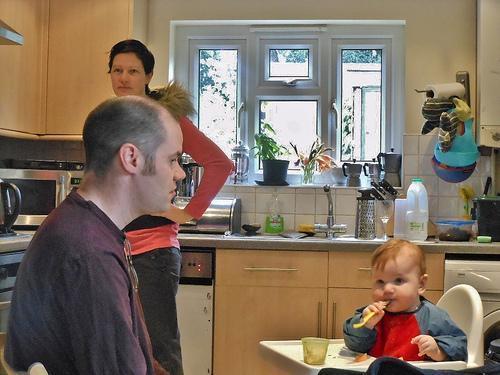How many objects on the window sill over the sink are made to hold coffee?
Give a very brief answer. 4. 